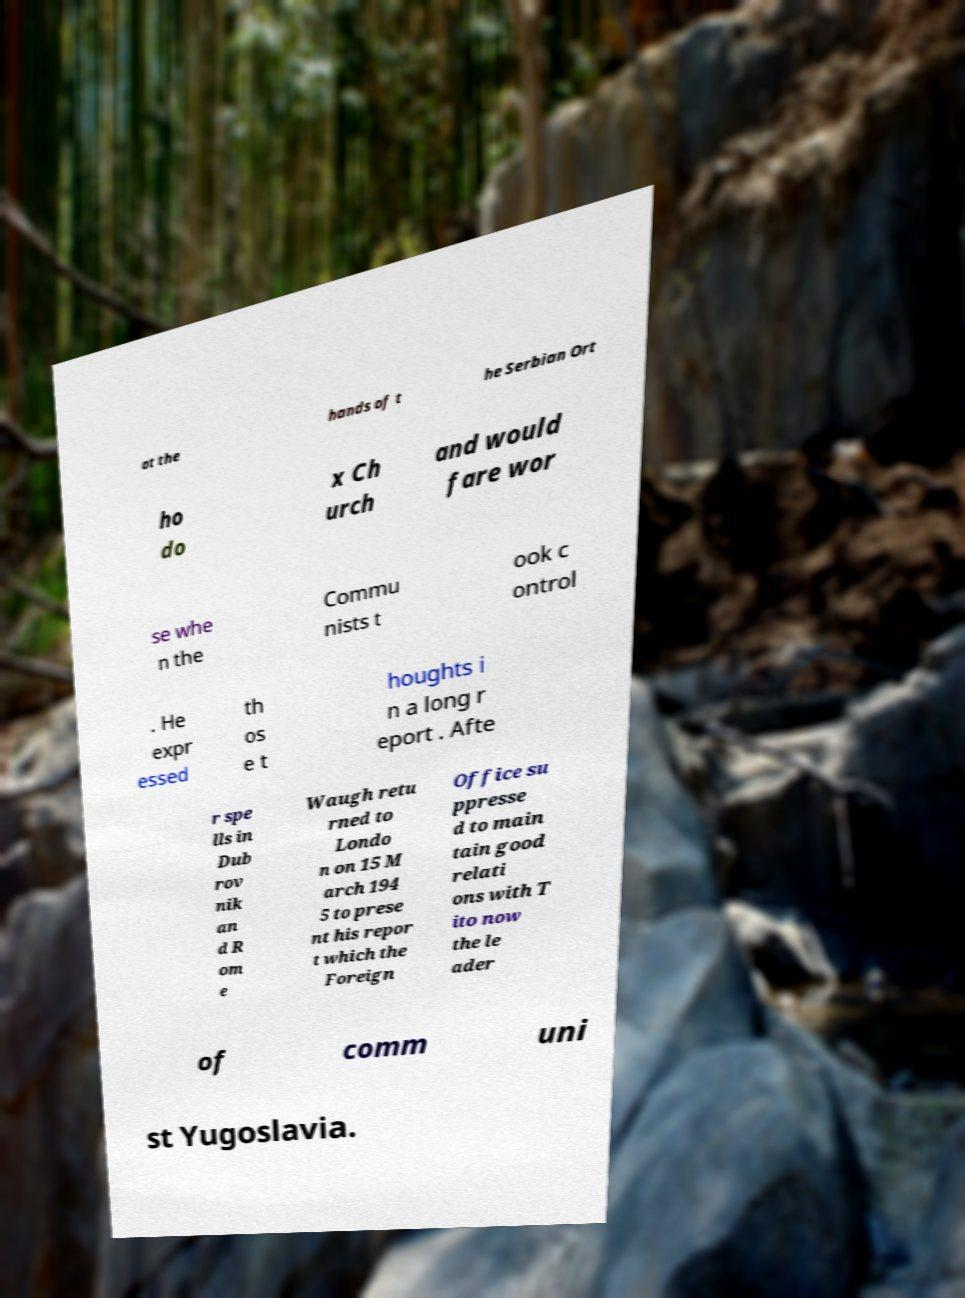Could you extract and type out the text from this image? at the hands of t he Serbian Ort ho do x Ch urch and would fare wor se whe n the Commu nists t ook c ontrol . He expr essed th os e t houghts i n a long r eport . Afte r spe lls in Dub rov nik an d R om e Waugh retu rned to Londo n on 15 M arch 194 5 to prese nt his repor t which the Foreign Office su ppresse d to main tain good relati ons with T ito now the le ader of comm uni st Yugoslavia. 